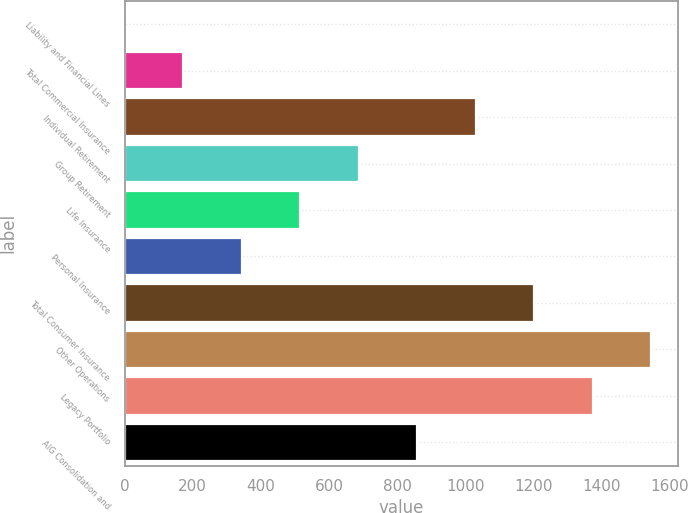<chart> <loc_0><loc_0><loc_500><loc_500><bar_chart><fcel>Liability and Financial Lines<fcel>Total Commercial Insurance<fcel>Individual Retirement<fcel>Group Retirement<fcel>Life Insurance<fcel>Personal Insurance<fcel>Total Consumer Insurance<fcel>Other Operations<fcel>Legacy Portfolio<fcel>AIG Consolidation and<nl><fcel>1<fcel>172.7<fcel>1031.2<fcel>687.8<fcel>516.1<fcel>344.4<fcel>1202.9<fcel>1546.3<fcel>1374.6<fcel>859.5<nl></chart> 